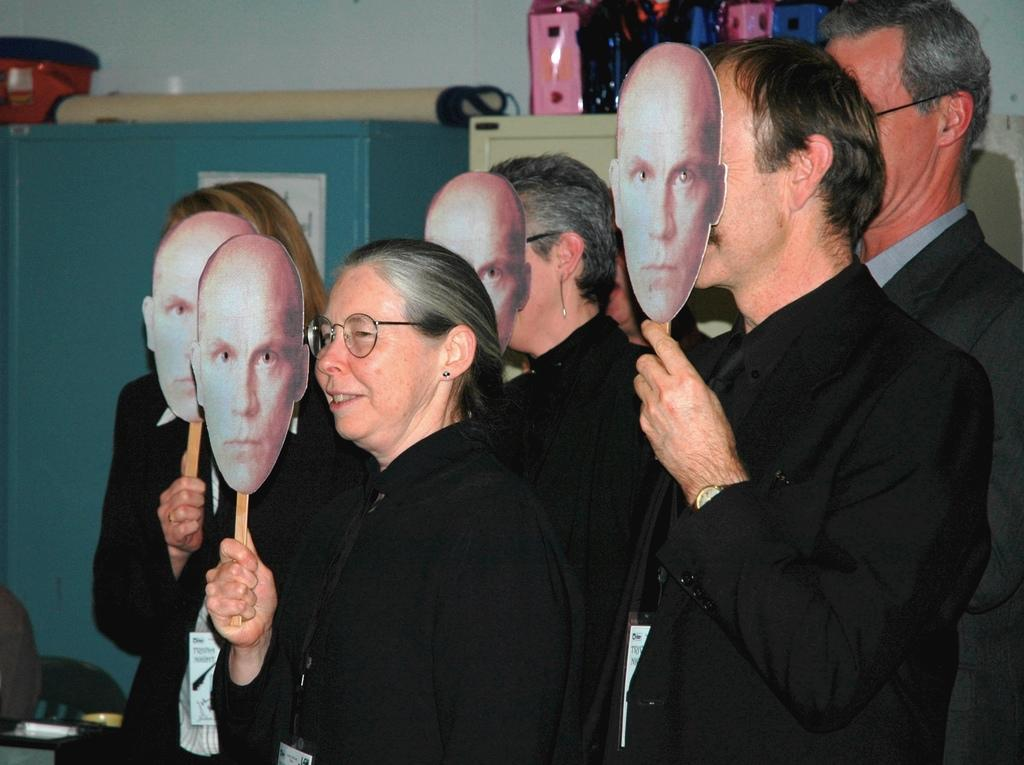What are the people in the image doing? The people in the image are standing and holding masks in their hands. What might the masks be used for? The masks might be used for protection or as part of a costume. What can be seen in the background of the image? There are cabinets in the background of the image. What is on top of the cabinets? There are objects on top of the cabinets. What is the weather like in the image? The provided facts do not mention the weather, so it cannot be determined from the image. What type of oven is visible in the image? There is no oven present in the image. 